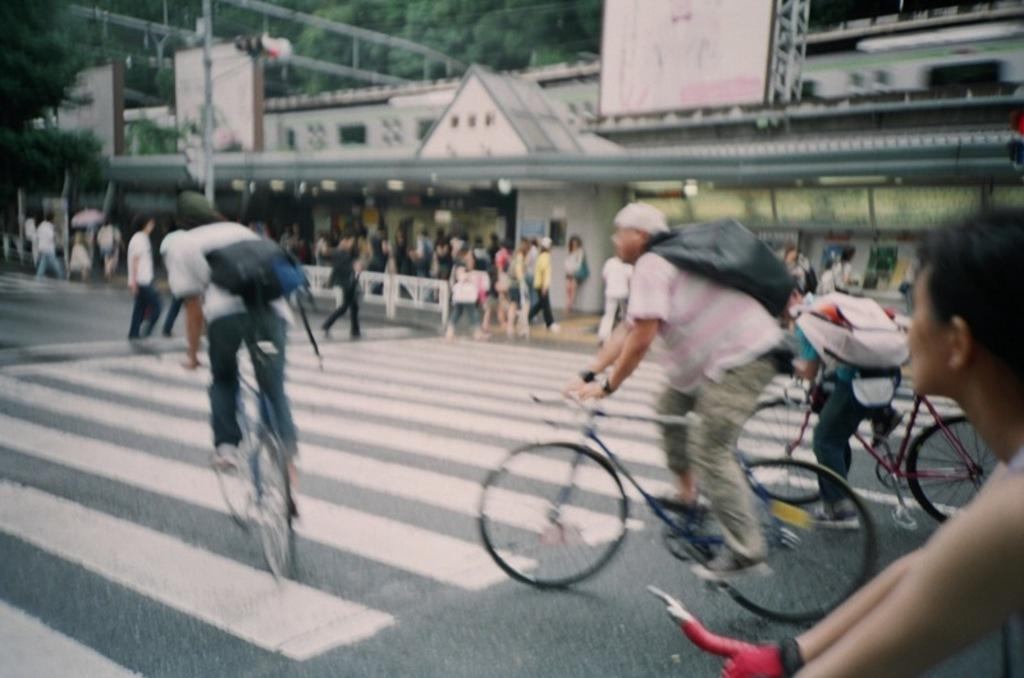How many people are in the image? There are multiple people in the image. What are some of the people doing in the image? Some of the people are on cycles, while the rest are on a path. What can be seen in the background of the image? There are trees and a train in the background of the image. What type of texture does the queen's dress have in the image? There is no queen present in the image, so there is no dress or texture to describe. 